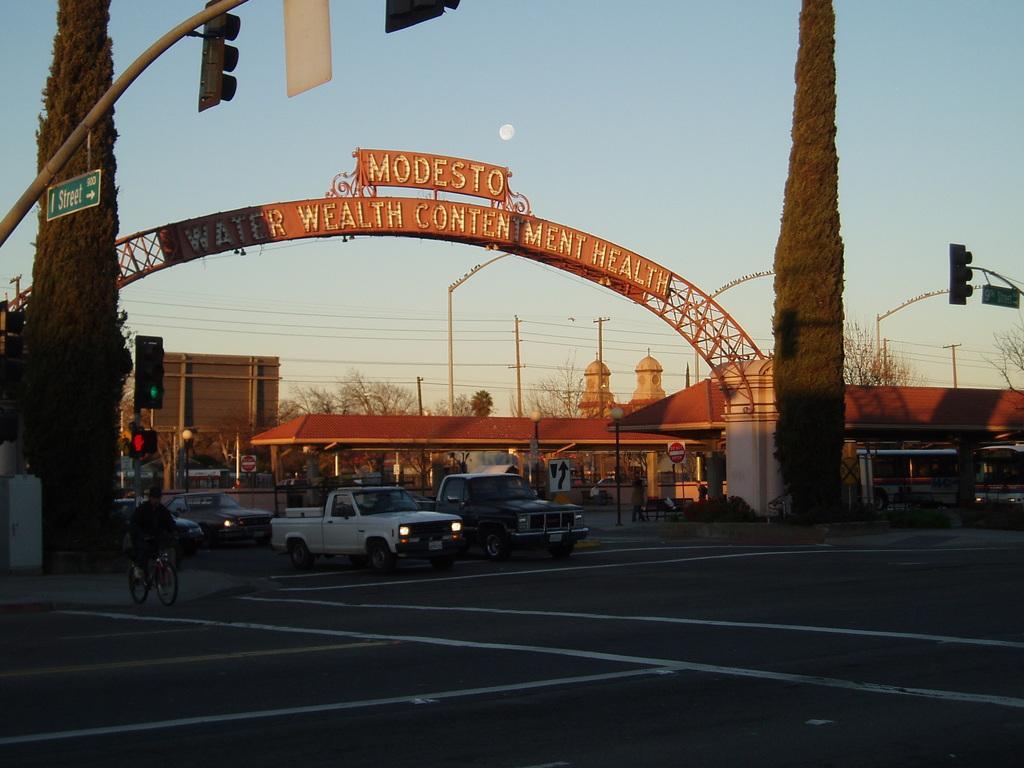In one or two sentences, can you explain what this image depicts? In this image we can see buildings, there is an arch with text on it, there are trees, wires connected to electric poles, there are light poles, a person is riding on the cycle, there are sign boards, vehicles on the road, also we can see the sky. 